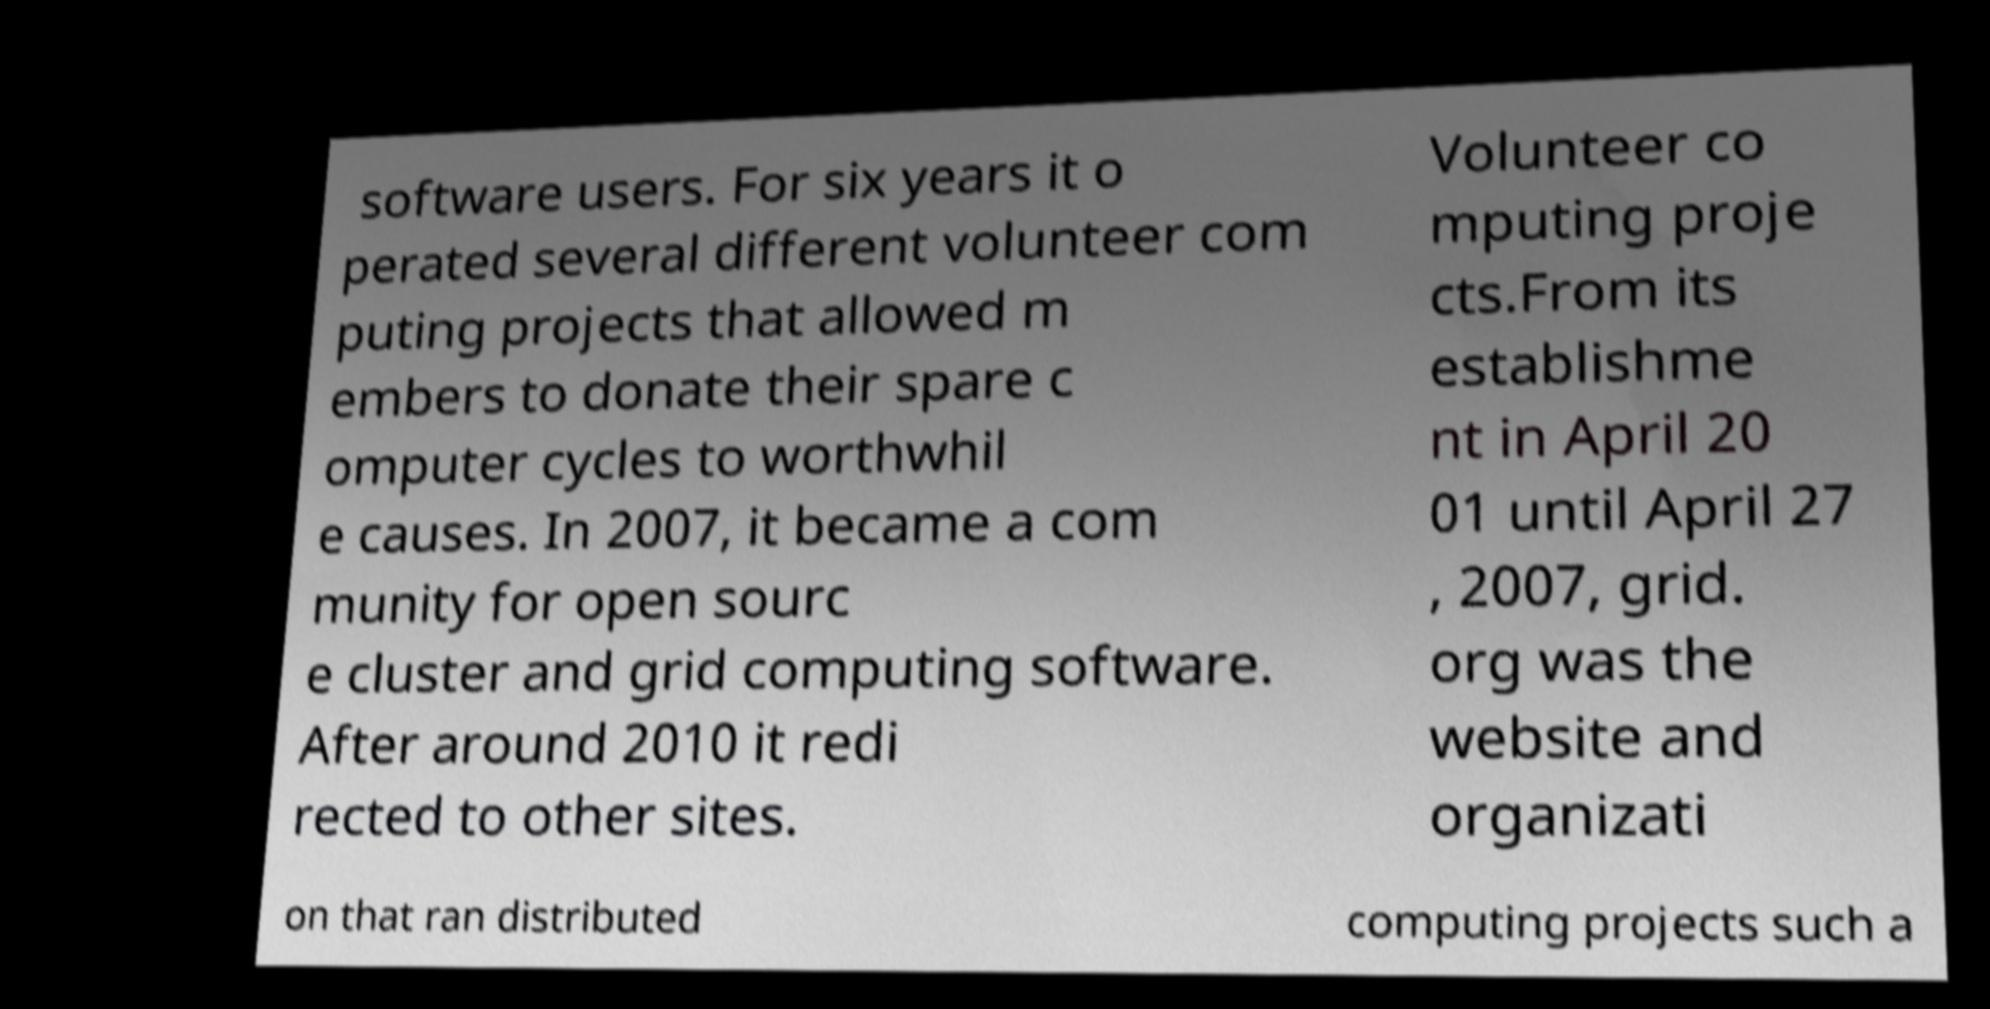I need the written content from this picture converted into text. Can you do that? software users. For six years it o perated several different volunteer com puting projects that allowed m embers to donate their spare c omputer cycles to worthwhil e causes. In 2007, it became a com munity for open sourc e cluster and grid computing software. After around 2010 it redi rected to other sites. Volunteer co mputing proje cts.From its establishme nt in April 20 01 until April 27 , 2007, grid. org was the website and organizati on that ran distributed computing projects such a 